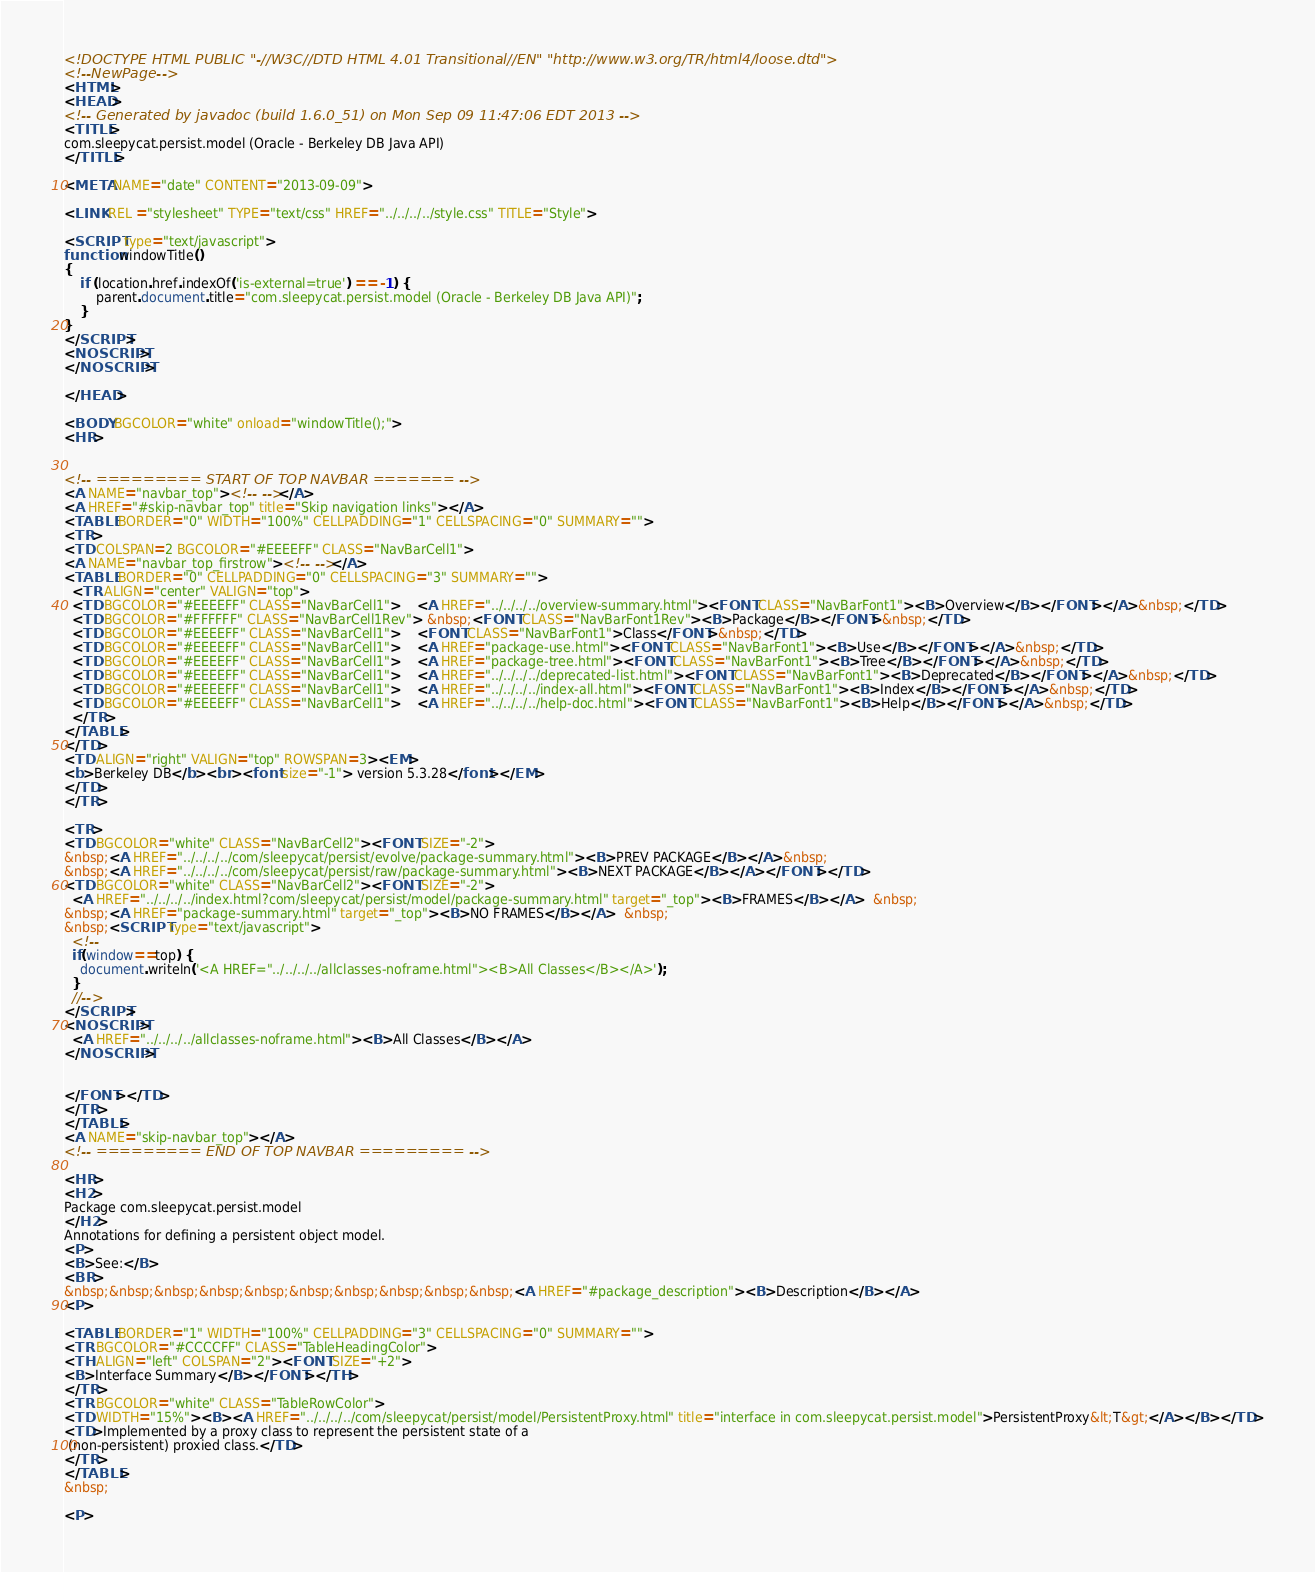<code> <loc_0><loc_0><loc_500><loc_500><_HTML_><!DOCTYPE HTML PUBLIC "-//W3C//DTD HTML 4.01 Transitional//EN" "http://www.w3.org/TR/html4/loose.dtd">
<!--NewPage-->
<HTML>
<HEAD>
<!-- Generated by javadoc (build 1.6.0_51) on Mon Sep 09 11:47:06 EDT 2013 -->
<TITLE>
com.sleepycat.persist.model (Oracle - Berkeley DB Java API)
</TITLE>

<META NAME="date" CONTENT="2013-09-09">

<LINK REL ="stylesheet" TYPE="text/css" HREF="../../../../style.css" TITLE="Style">

<SCRIPT type="text/javascript">
function windowTitle()
{
    if (location.href.indexOf('is-external=true') == -1) {
        parent.document.title="com.sleepycat.persist.model (Oracle - Berkeley DB Java API)";
    }
}
</SCRIPT>
<NOSCRIPT>
</NOSCRIPT>

</HEAD>

<BODY BGCOLOR="white" onload="windowTitle();">
<HR>


<!-- ========= START OF TOP NAVBAR ======= -->
<A NAME="navbar_top"><!-- --></A>
<A HREF="#skip-navbar_top" title="Skip navigation links"></A>
<TABLE BORDER="0" WIDTH="100%" CELLPADDING="1" CELLSPACING="0" SUMMARY="">
<TR>
<TD COLSPAN=2 BGCOLOR="#EEEEFF" CLASS="NavBarCell1">
<A NAME="navbar_top_firstrow"><!-- --></A>
<TABLE BORDER="0" CELLPADDING="0" CELLSPACING="3" SUMMARY="">
  <TR ALIGN="center" VALIGN="top">
  <TD BGCOLOR="#EEEEFF" CLASS="NavBarCell1">    <A HREF="../../../../overview-summary.html"><FONT CLASS="NavBarFont1"><B>Overview</B></FONT></A>&nbsp;</TD>
  <TD BGCOLOR="#FFFFFF" CLASS="NavBarCell1Rev"> &nbsp;<FONT CLASS="NavBarFont1Rev"><B>Package</B></FONT>&nbsp;</TD>
  <TD BGCOLOR="#EEEEFF" CLASS="NavBarCell1">    <FONT CLASS="NavBarFont1">Class</FONT>&nbsp;</TD>
  <TD BGCOLOR="#EEEEFF" CLASS="NavBarCell1">    <A HREF="package-use.html"><FONT CLASS="NavBarFont1"><B>Use</B></FONT></A>&nbsp;</TD>
  <TD BGCOLOR="#EEEEFF" CLASS="NavBarCell1">    <A HREF="package-tree.html"><FONT CLASS="NavBarFont1"><B>Tree</B></FONT></A>&nbsp;</TD>
  <TD BGCOLOR="#EEEEFF" CLASS="NavBarCell1">    <A HREF="../../../../deprecated-list.html"><FONT CLASS="NavBarFont1"><B>Deprecated</B></FONT></A>&nbsp;</TD>
  <TD BGCOLOR="#EEEEFF" CLASS="NavBarCell1">    <A HREF="../../../../index-all.html"><FONT CLASS="NavBarFont1"><B>Index</B></FONT></A>&nbsp;</TD>
  <TD BGCOLOR="#EEEEFF" CLASS="NavBarCell1">    <A HREF="../../../../help-doc.html"><FONT CLASS="NavBarFont1"><B>Help</B></FONT></A>&nbsp;</TD>
  </TR>
</TABLE>
</TD>
<TD ALIGN="right" VALIGN="top" ROWSPAN=3><EM>
<b>Berkeley DB</b><br><font size="-1"> version 5.3.28</font></EM>
</TD>
</TR>

<TR>
<TD BGCOLOR="white" CLASS="NavBarCell2"><FONT SIZE="-2">
&nbsp;<A HREF="../../../../com/sleepycat/persist/evolve/package-summary.html"><B>PREV PACKAGE</B></A>&nbsp;
&nbsp;<A HREF="../../../../com/sleepycat/persist/raw/package-summary.html"><B>NEXT PACKAGE</B></A></FONT></TD>
<TD BGCOLOR="white" CLASS="NavBarCell2"><FONT SIZE="-2">
  <A HREF="../../../../index.html?com/sleepycat/persist/model/package-summary.html" target="_top"><B>FRAMES</B></A>  &nbsp;
&nbsp;<A HREF="package-summary.html" target="_top"><B>NO FRAMES</B></A>  &nbsp;
&nbsp;<SCRIPT type="text/javascript">
  <!--
  if(window==top) {
    document.writeln('<A HREF="../../../../allclasses-noframe.html"><B>All Classes</B></A>');
  }
  //-->
</SCRIPT>
<NOSCRIPT>
  <A HREF="../../../../allclasses-noframe.html"><B>All Classes</B></A>
</NOSCRIPT>


</FONT></TD>
</TR>
</TABLE>
<A NAME="skip-navbar_top"></A>
<!-- ========= END OF TOP NAVBAR ========= -->

<HR>
<H2>
Package com.sleepycat.persist.model
</H2>
Annotations for defining a persistent object model.
<P>
<B>See:</B>
<BR>
&nbsp;&nbsp;&nbsp;&nbsp;&nbsp;&nbsp;&nbsp;&nbsp;&nbsp;&nbsp;<A HREF="#package_description"><B>Description</B></A>
<P>

<TABLE BORDER="1" WIDTH="100%" CELLPADDING="3" CELLSPACING="0" SUMMARY="">
<TR BGCOLOR="#CCCCFF" CLASS="TableHeadingColor">
<TH ALIGN="left" COLSPAN="2"><FONT SIZE="+2">
<B>Interface Summary</B></FONT></TH>
</TR>
<TR BGCOLOR="white" CLASS="TableRowColor">
<TD WIDTH="15%"><B><A HREF="../../../../com/sleepycat/persist/model/PersistentProxy.html" title="interface in com.sleepycat.persist.model">PersistentProxy&lt;T&gt;</A></B></TD>
<TD>Implemented by a proxy class to represent the persistent state of a
 (non-persistent) proxied class.</TD>
</TR>
</TABLE>
&nbsp;

<P>
</code> 